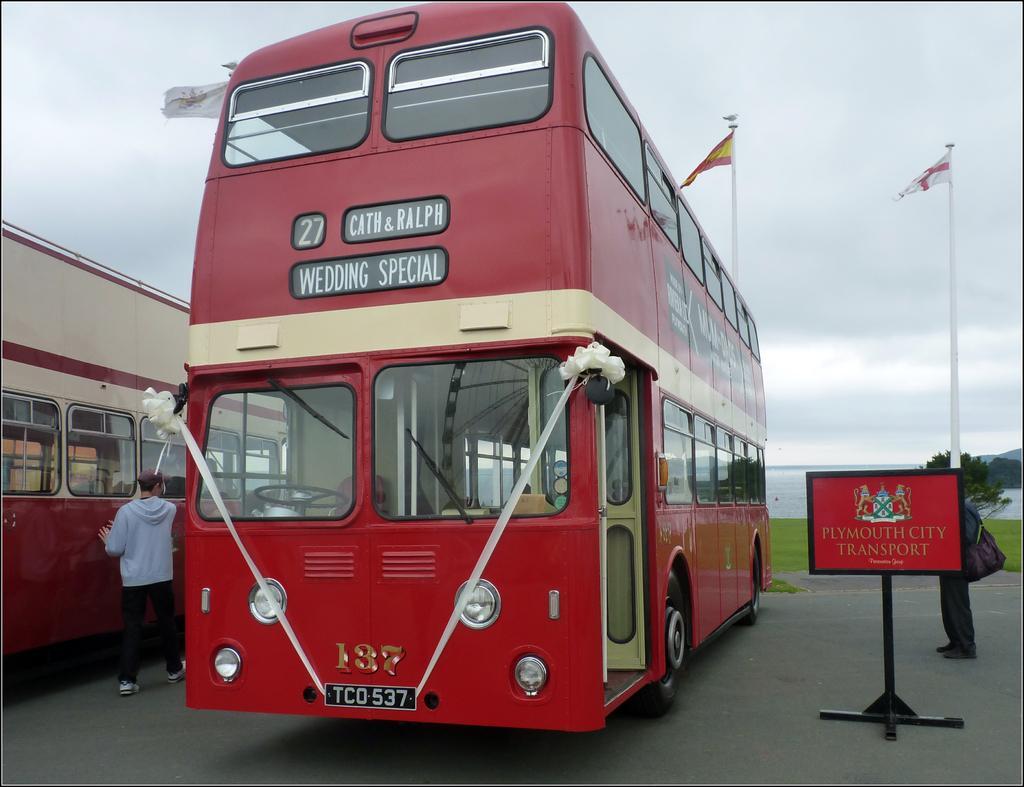Please provide a concise description of this image. At the bottom of the image there is road. On the road there are buses with glasses, glass windows, names and numbers on it. On the left side of the image beside the bus there is a man standing. On the right side of the image there is a pole with board with something written on it. Behind the pole there is a person standing. In the background on the ground there is grass. And also there is tree. At the top of the image there is sky. 